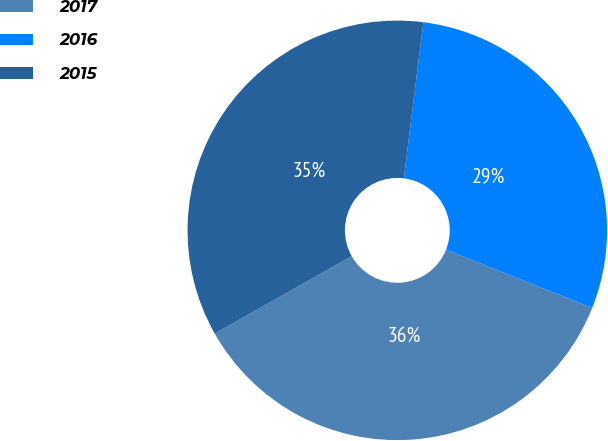Convert chart. <chart><loc_0><loc_0><loc_500><loc_500><pie_chart><fcel>2017<fcel>2016<fcel>2015<nl><fcel>35.79%<fcel>29.04%<fcel>35.17%<nl></chart> 